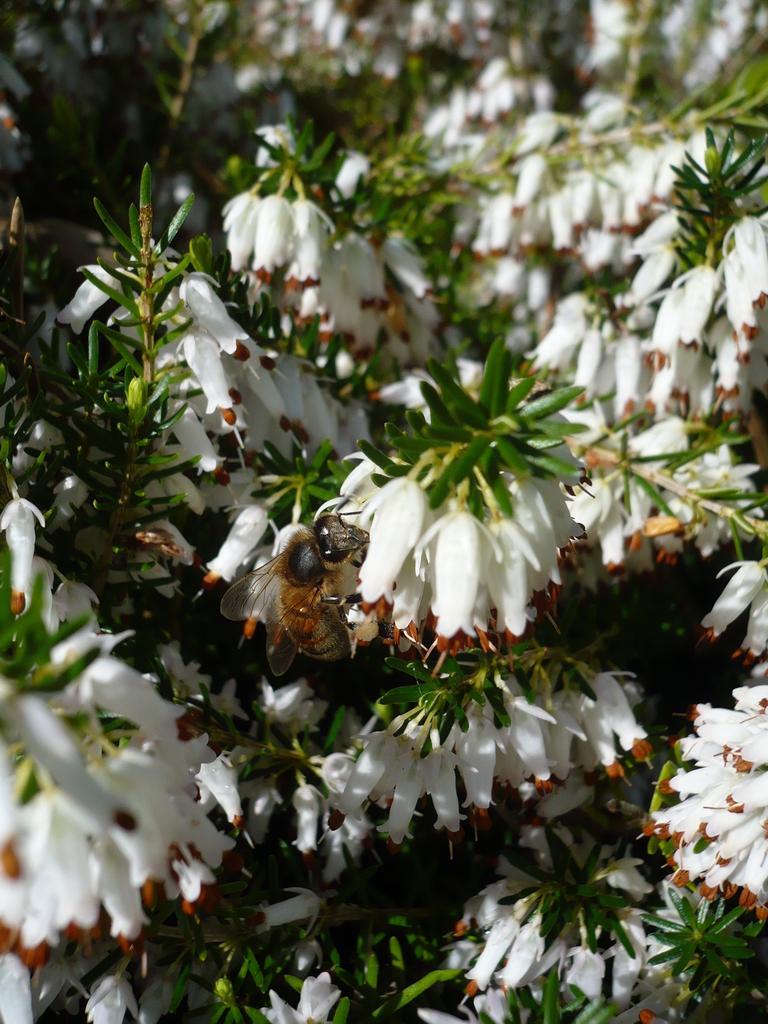Describe this image in one or two sentences. In this image there are flowers, on that flowers there is a honey bee. 